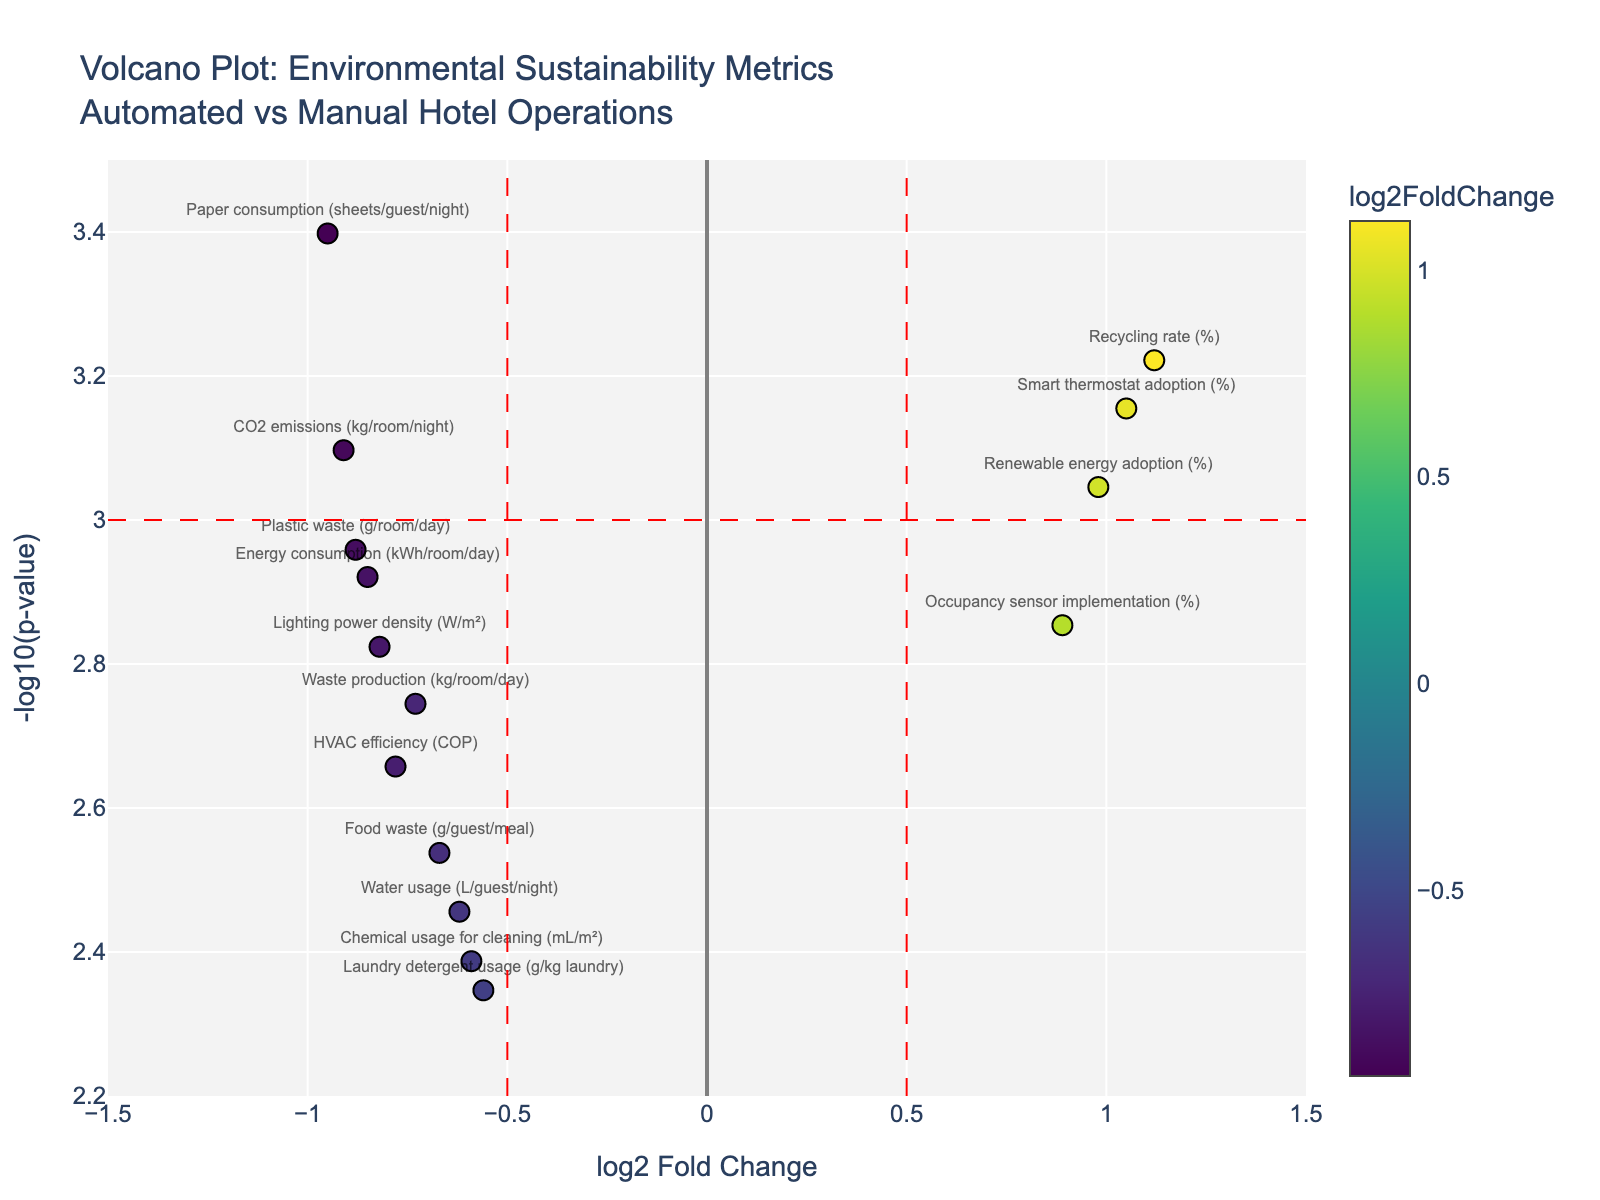How many metrics are plotted on the volcano plot? To determine the number of metrics, count the distinct data points on the plot. Each unique label represents a different metric.
Answer: 15 What is the title of the plot? The title can be found at the top center of the volcano plot. It provides an overview of what the plot represents.
Answer: Volcano Plot: Environmental Sustainability Metrics<br>Automated vs Manual Hotel Operations Which metric has the smallest p-value? Examine the y-axis, which represents -log10(p-value). The metric with the highest position on this axis has the smallest p-value.
Answer: Paper consumption (sheets/guest/night) What number of metrics show log2FoldChange greater than 0.5? Identify the data points to the right of the vertical line at log2FoldChange = 0.5. Count these data points.
Answer: 3 Which two metrics have the most negative log2FoldChange? Inspect the left side of the plot for the two points farthest to the left.
Answer: Paper consumption (sheets/guest/night) and CO2 emissions (kg/room/night) Does Energy consumption (kWh/room/day) have a positive or negative log2FoldChange? Locate the marker for Energy consumption and check if it is situated on the left (negative) or right (positive) side of the origin (log2FoldChange = 0).
Answer: Negative What's the difference in log2FoldChange between Smart thermostat adoption and HVAC efficiency? Find the log2FoldChange values for Smart thermostat adoption (1.05) and HVAC efficiency (-0.78). Subtract the log2FoldChange of HVAC efficiency from that of Smart thermostat adoption.
Answer: 1.83 Which metric is nearest to the origin in terms of log2FoldChange? Examine the points near the x-axis origin (log2FoldChange = 0) and determine the closest one.
Answer: Laundry detergent usage (g/kg laundry) Which metric has the highest positive log2FoldChange? Locate the point farthest to the right on the x-axis and identify the corresponding metric.
Answer: Recycling rate (%) 